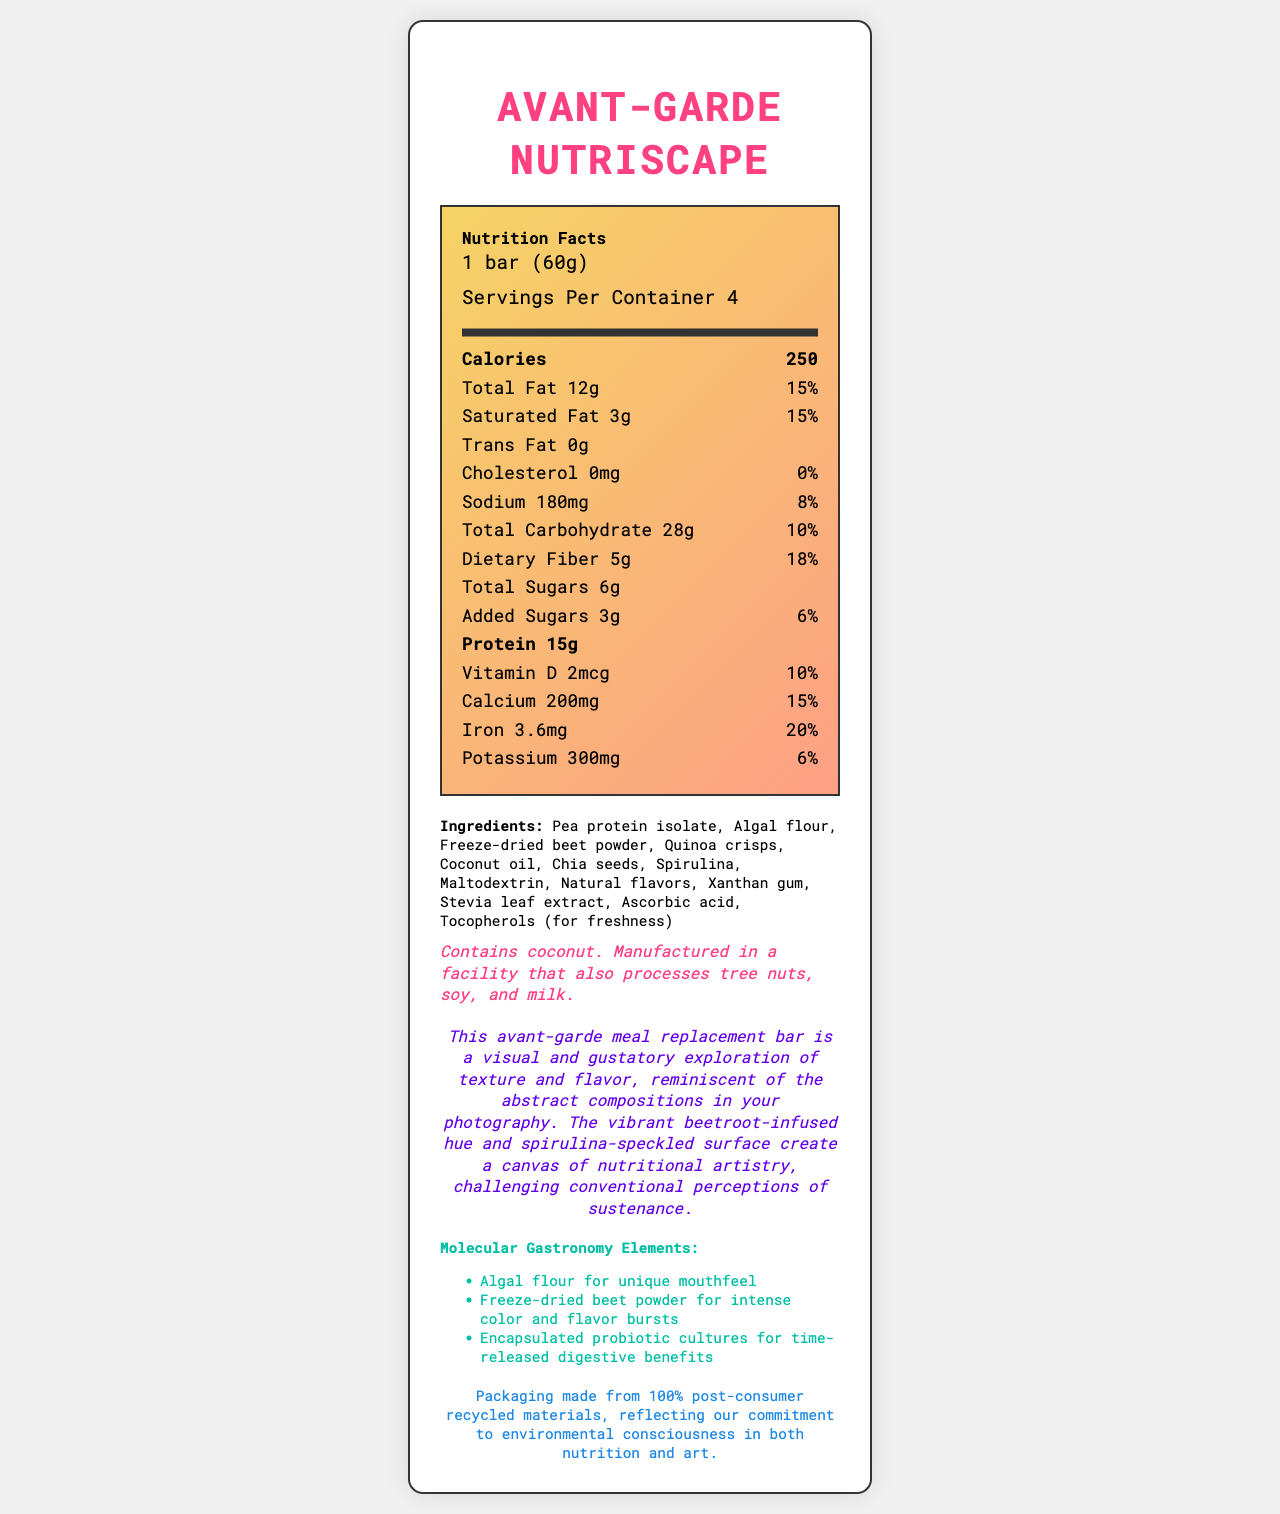what is the serving size of the Avant-Garde Nutriscape? The serving size is explicitly mentioned at the top of the document under the "Nutrition Facts" section.
Answer: 1 bar (60g) how many servings are there per container? The number of servings per container is specified as "Servings Per Container 4" right below the serving size information.
Answer: 4 how many calories are in one serving? The calorie content per serving is clearly listed as "Calories 250" in the "Nutrition Facts" section.
Answer: 250 list three main components of the molecular gastronomy elements in this product. These elements are listed under the "Molecular Gastronomy Elements" section at the bottom of the document.
Answer: Algal flour, Freeze-dried beet powder, Encapsulated probiotic cultures which nutrient has the highest percentage daily value? Iron has a daily value of 20%, which is the highest among the listed nutrients.
Answer: Iron what is the total amount of sugars in the bar? The total sugar content is indicated as "Total Sugars 6g" under the "Nutrition Facts" section.
Answer: 6g what are the three potential allergens in this bar? The allergen information is stated in the italicized "allergen_info" section and mentions that the product contains coconut and is processed in a facility that handles tree nuts, soy, and milk.
Answer: Coconut, tree nuts, soy, and milk how much dietary fiber does this bar contain per serving? The amount of dietary fiber is listed as "Dietary Fiber 5g" under the "Nutrition Facts" section.
Answer: 5g how does the bar contribute to sustainability? A. Ingredients sourced locally B. Packaging made from 100% post-consumer recycled materials C. Biodegradable packaging D. No palm oil usage The document mentions "Packaging made from 100% post-consumer recycled materials" in the sustainability note.
Answer: B. Packaging made from 100% post-consumer recycled materials what is the protein content per serving? Protein content is listed as "Protein 15g" in the "Nutrition Facts" section.
Answer: 15g which of the following is not an ingredient in the bar? i. Quinoa crisps ii. Algal flour iii. Artificial flavors iv. Xanthan gum The ingredient list on the document does not include artificial flavors, but it does include quinoa crisps, algal flour, and xanthan gum.
Answer: iii. Artificial flavors is there any cholesterol in this bar? The "Cholesterol 0mg" with a daily value of 0% confirms that the bar contains no cholesterol.
Answer: No summarize the main idea of the document. The "Nutrition Facts" section details the nutritional content per serving, including calories, fats, sugars, proteins, vitamins, and minerals. It also lists ingredients, potential allergens, unique molecular gastronomy components, and notes the product's visual and textural artistry. Finally, it highlights the bar's environmentally-conscious packaging.
Answer: The document provides detailed nutritional information, a list of ingredients, allergen warnings, molecular gastronomy elements, an artistic description, and a sustainability note for the Avant-Garde Nutriscape meal replacement bar. what is the exact percentage of daily value for added sugars? The added sugars have a daily value listed as "6%" under the "Nutrition Facts" section.
Answer: 6% how much Vitamin D is present in one serving? The amount of Vitamin D is listed as "Vitamin D 2mcg" in the "Nutrition Facts" section.
Answer: 2mcg can we determine the price of the Avant-Garde Nutriscape from the document? The document provides detailed nutritional and ingredient information but does not mention the price.
Answer: Not enough information what are the natural components used for flavoring in the bar? The ingredients list includes "Natural flavors" as one of the components.
Answer: Natural flavors which oil is used in the Avant-Garde Nutriscape? The ingredients list explicitly mentions "Coconut oil".
Answer: Coconut oil 